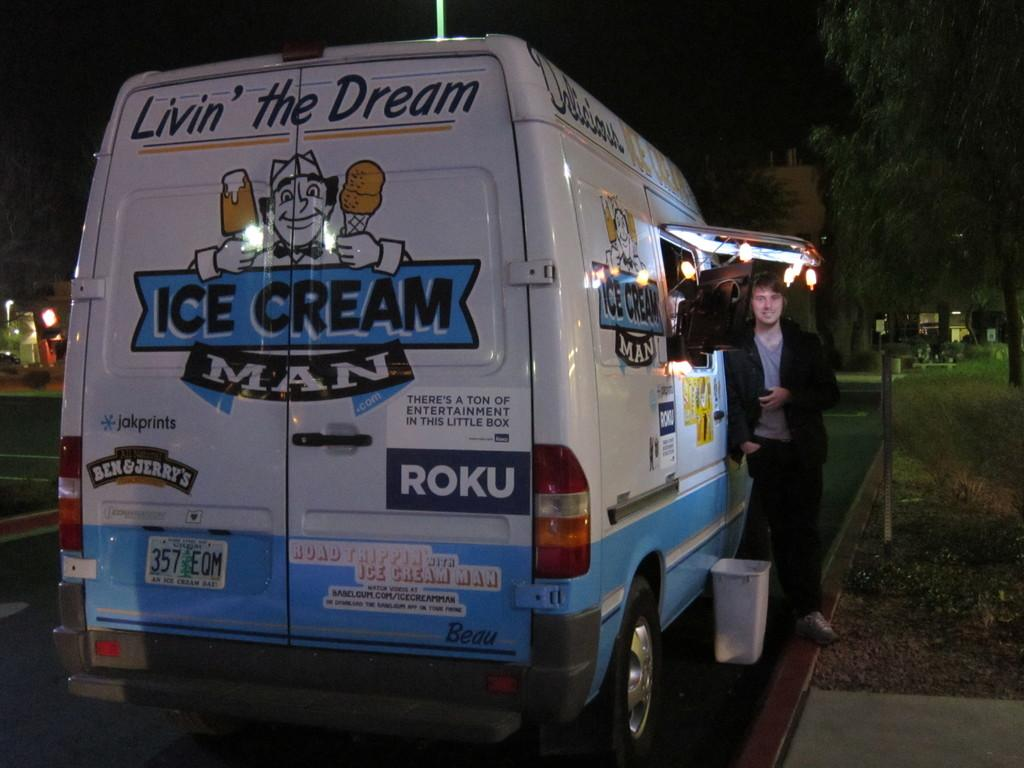Provide a one-sentence caption for the provided image. Man standing next to a blue and white van on which the words "Livin' the Dream" and "Ice Cream Man" are displayed. 